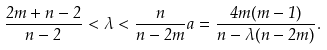<formula> <loc_0><loc_0><loc_500><loc_500>\frac { 2 m + n - 2 } { n - 2 } < \lambda < \frac { n } { n - 2 m } a = \frac { 4 m ( m - 1 ) } { n - \lambda ( n - 2 m ) } .</formula> 